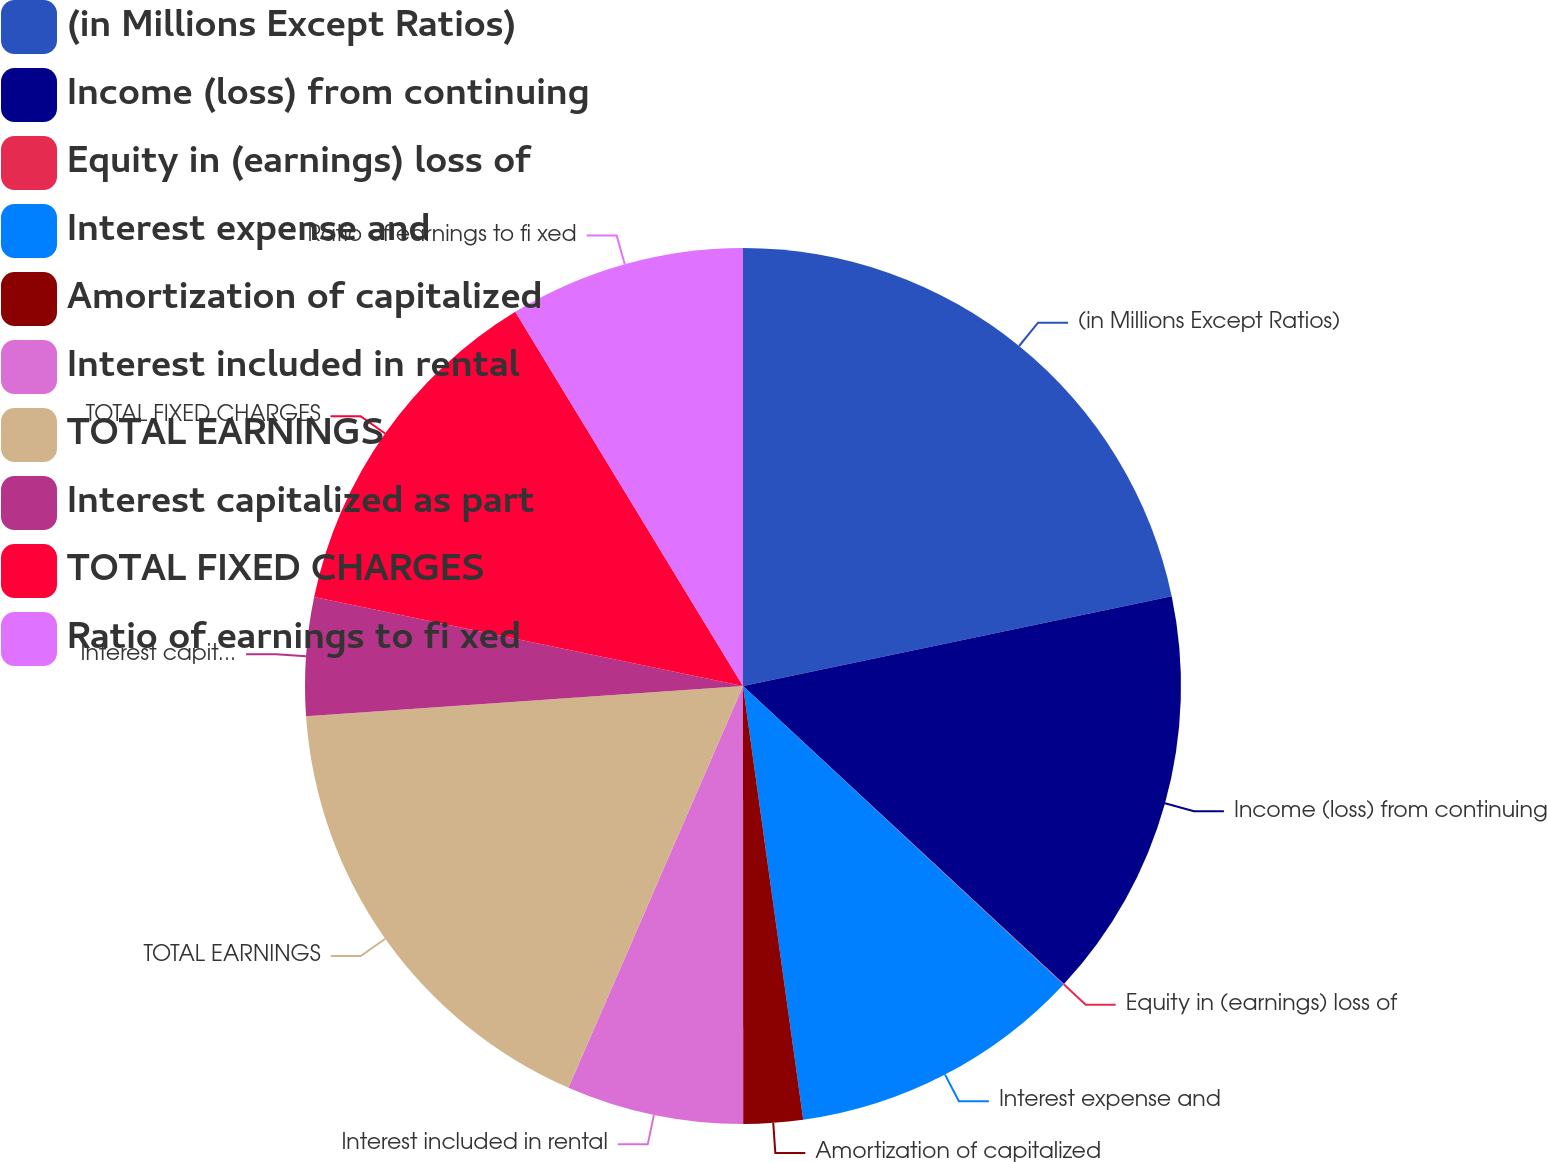Convert chart to OTSL. <chart><loc_0><loc_0><loc_500><loc_500><pie_chart><fcel>(in Millions Except Ratios)<fcel>Income (loss) from continuing<fcel>Equity in (earnings) loss of<fcel>Interest expense and<fcel>Amortization of capitalized<fcel>Interest included in rental<fcel>TOTAL EARNINGS<fcel>Interest capitalized as part<fcel>TOTAL FIXED CHARGES<fcel>Ratio of earnings to fi xed<nl><fcel>21.71%<fcel>15.2%<fcel>0.02%<fcel>10.87%<fcel>2.19%<fcel>6.53%<fcel>17.37%<fcel>4.36%<fcel>13.04%<fcel>8.7%<nl></chart> 